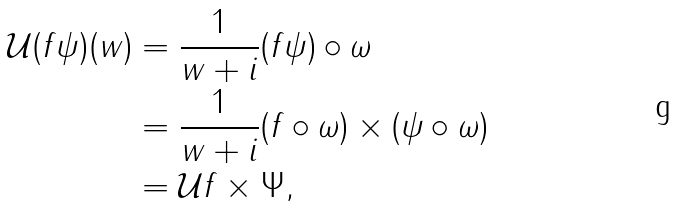Convert formula to latex. <formula><loc_0><loc_0><loc_500><loc_500>\mathcal { U } ( f \psi ) ( w ) & = \frac { 1 } { w + i } ( f \psi ) \circ \omega \\ & = \frac { 1 } { w + i } ( f \circ \omega ) \times ( \psi \circ \omega ) \\ & = \mathcal { U } f \times \Psi ,</formula> 